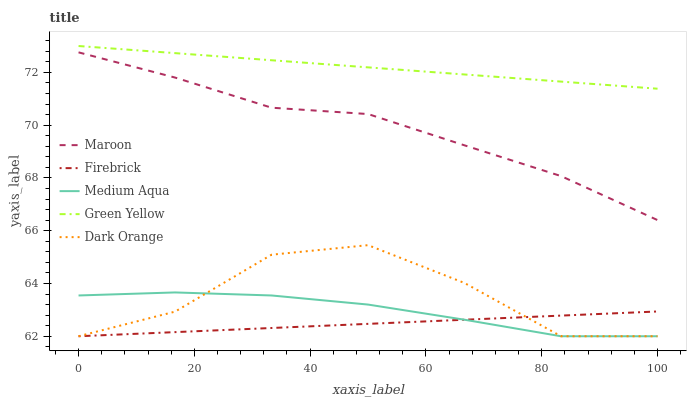Does Firebrick have the minimum area under the curve?
Answer yes or no. Yes. Does Green Yellow have the maximum area under the curve?
Answer yes or no. Yes. Does Green Yellow have the minimum area under the curve?
Answer yes or no. No. Does Firebrick have the maximum area under the curve?
Answer yes or no. No. Is Firebrick the smoothest?
Answer yes or no. Yes. Is Dark Orange the roughest?
Answer yes or no. Yes. Is Green Yellow the smoothest?
Answer yes or no. No. Is Green Yellow the roughest?
Answer yes or no. No. Does Dark Orange have the lowest value?
Answer yes or no. Yes. Does Green Yellow have the lowest value?
Answer yes or no. No. Does Green Yellow have the highest value?
Answer yes or no. Yes. Does Firebrick have the highest value?
Answer yes or no. No. Is Maroon less than Green Yellow?
Answer yes or no. Yes. Is Maroon greater than Dark Orange?
Answer yes or no. Yes. Does Firebrick intersect Dark Orange?
Answer yes or no. Yes. Is Firebrick less than Dark Orange?
Answer yes or no. No. Is Firebrick greater than Dark Orange?
Answer yes or no. No. Does Maroon intersect Green Yellow?
Answer yes or no. No. 